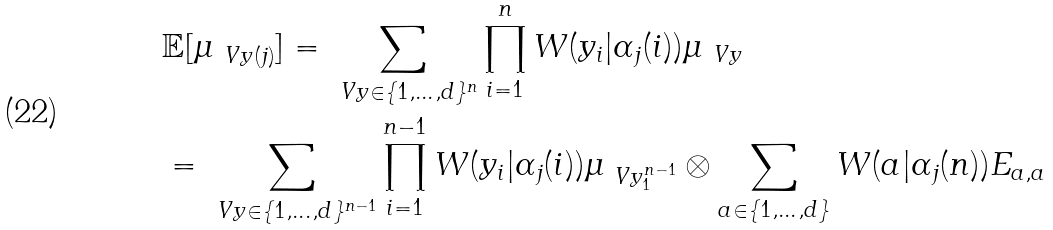<formula> <loc_0><loc_0><loc_500><loc_500>& \mathbb { E } [ \mu _ { \ V y ( j ) } ] = \sum _ { \ V y \in \{ 1 , \dots , d \} ^ { n } } \prod _ { i = 1 } ^ { n } W ( y _ { i } | \alpha _ { j } ( i ) ) \mu _ { \ V y } \\ & = \sum _ { \ V y \in \{ 1 , \dots , d \} ^ { n - 1 } } \prod _ { i = 1 } ^ { n - 1 } W ( y _ { i } | \alpha _ { j } ( i ) ) \mu _ { \ V y _ { 1 } ^ { n - 1 } } \otimes \sum _ { a \in \{ 1 , \dots , d \} } W ( a | \alpha _ { j } ( n ) ) E _ { a , a }</formula> 